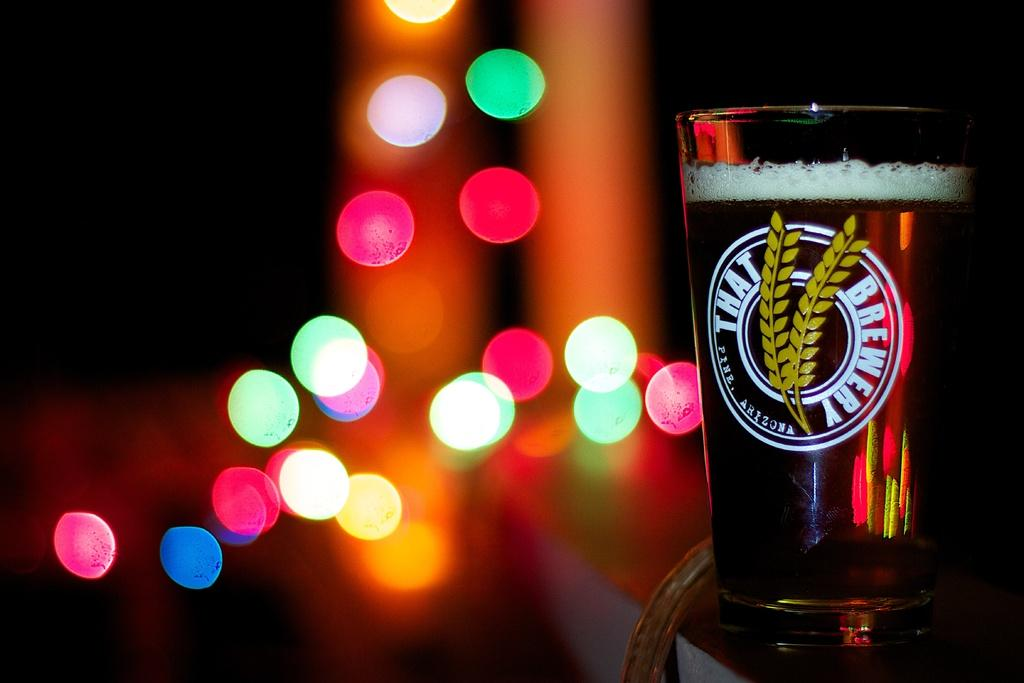<image>
Describe the image concisely. Bottle of beer which says "That Brewery" on the cup. 